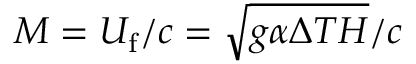<formula> <loc_0><loc_0><loc_500><loc_500>M = U _ { f } / c = \sqrt { g \alpha \Delta T H } / c</formula> 